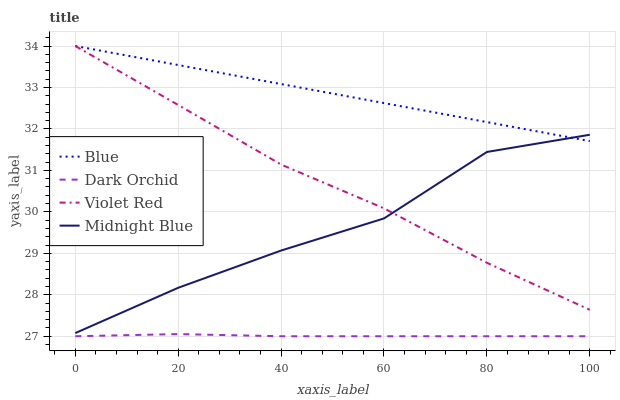Does Dark Orchid have the minimum area under the curve?
Answer yes or no. Yes. Does Blue have the maximum area under the curve?
Answer yes or no. Yes. Does Violet Red have the minimum area under the curve?
Answer yes or no. No. Does Violet Red have the maximum area under the curve?
Answer yes or no. No. Is Blue the smoothest?
Answer yes or no. Yes. Is Midnight Blue the roughest?
Answer yes or no. Yes. Is Violet Red the smoothest?
Answer yes or no. No. Is Violet Red the roughest?
Answer yes or no. No. Does Dark Orchid have the lowest value?
Answer yes or no. Yes. Does Violet Red have the lowest value?
Answer yes or no. No. Does Violet Red have the highest value?
Answer yes or no. Yes. Does Midnight Blue have the highest value?
Answer yes or no. No. Is Dark Orchid less than Blue?
Answer yes or no. Yes. Is Blue greater than Dark Orchid?
Answer yes or no. Yes. Does Midnight Blue intersect Violet Red?
Answer yes or no. Yes. Is Midnight Blue less than Violet Red?
Answer yes or no. No. Is Midnight Blue greater than Violet Red?
Answer yes or no. No. Does Dark Orchid intersect Blue?
Answer yes or no. No. 